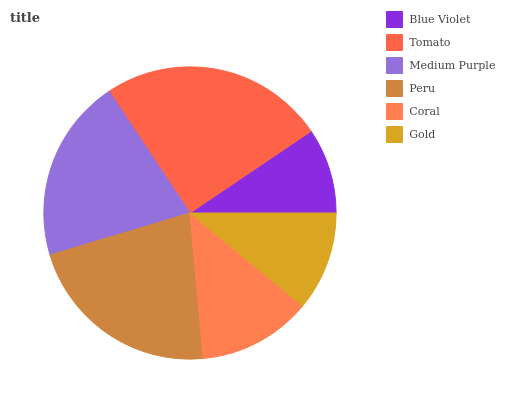Is Blue Violet the minimum?
Answer yes or no. Yes. Is Tomato the maximum?
Answer yes or no. Yes. Is Medium Purple the minimum?
Answer yes or no. No. Is Medium Purple the maximum?
Answer yes or no. No. Is Tomato greater than Medium Purple?
Answer yes or no. Yes. Is Medium Purple less than Tomato?
Answer yes or no. Yes. Is Medium Purple greater than Tomato?
Answer yes or no. No. Is Tomato less than Medium Purple?
Answer yes or no. No. Is Medium Purple the high median?
Answer yes or no. Yes. Is Coral the low median?
Answer yes or no. Yes. Is Peru the high median?
Answer yes or no. No. Is Tomato the low median?
Answer yes or no. No. 